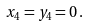Convert formula to latex. <formula><loc_0><loc_0><loc_500><loc_500>x _ { 4 } = y _ { 4 } = 0 \, .</formula> 